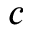Convert formula to latex. <formula><loc_0><loc_0><loc_500><loc_500>c</formula> 